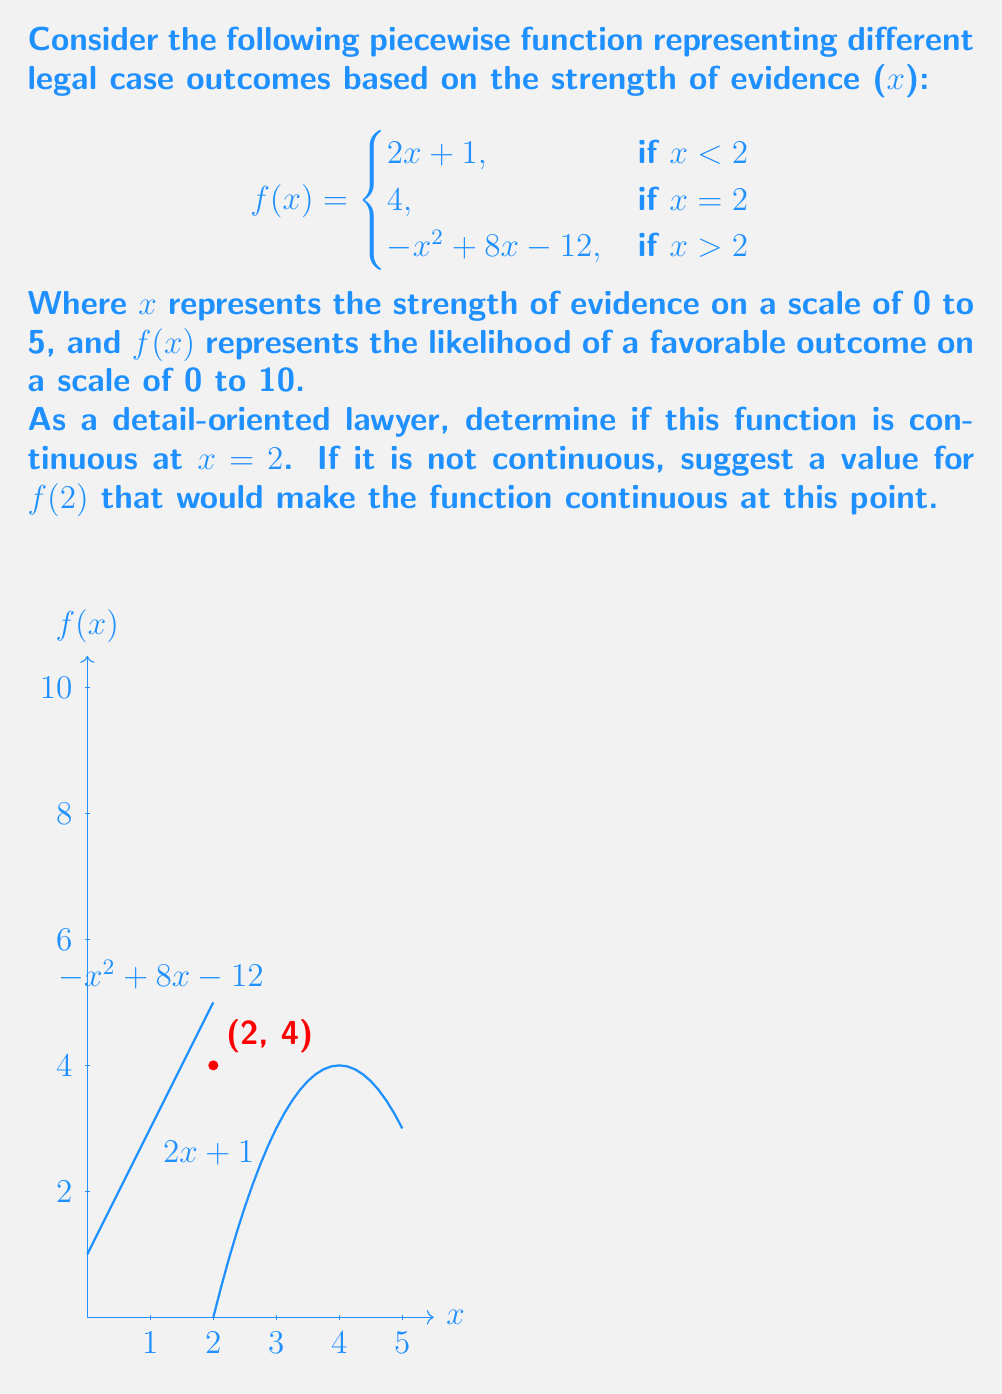Give your solution to this math problem. To determine if the function is continuous at x = 2, we need to check three conditions:

1. f(2) is defined
2. $\lim_{x \to 2^-} f(x)$ exists
3. $\lim_{x \to 2^+} f(x)$ exists
4. $\lim_{x \to 2^-} f(x) = \lim_{x \to 2^+} f(x) = f(2)$

Step 1: f(2) is defined and equals 4.

Step 2: Calculate $\lim_{x \to 2^-} f(x)$
$$\lim_{x \to 2^-} f(x) = \lim_{x \to 2^-} (2x + 1) = 2(2) + 1 = 5$$

Step 3: Calculate $\lim_{x \to 2^+} f(x)$
$$\lim_{x \to 2^+} f(x) = \lim_{x \to 2^+} (-x^2 + 8x - 12) = -(2)^2 + 8(2) - 12 = 4$$

Step 4: Check if all limits are equal
$\lim_{x \to 2^-} f(x) = 5$
$\lim_{x \to 2^+} f(x) = 4$
$f(2) = 4$

The function is not continuous at x = 2 because $\lim_{x \to 2^-} f(x) \neq \lim_{x \to 2^+} f(x)$.

To make the function continuous at x = 2, we need to change f(2) to 5, which is the value of $\lim_{x \to 2^-} f(x)$. This would satisfy all conditions for continuity.
Answer: Not continuous at x = 2. Change f(2) to 5 for continuity. 